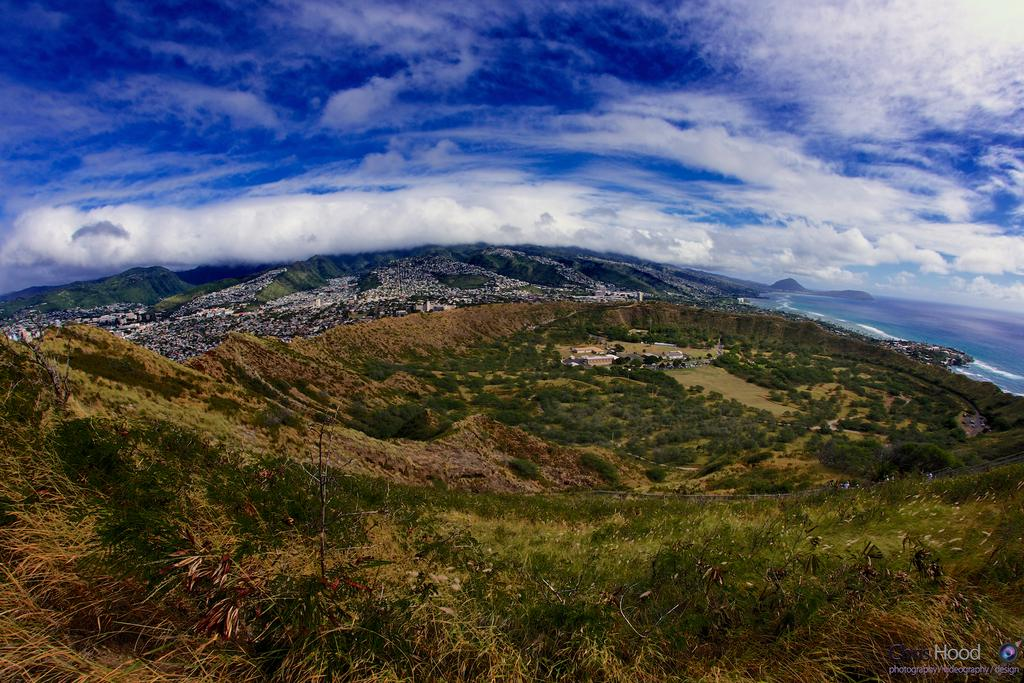What type of landscape is depicted in the image? There is a mountain valley in the image. What can be seen in the valley? The valley is full of trees and dry grass. What is visible at the top of the image? The sky is visible at the top of the image. What can be observed in the sky? Clouds are present in the sky. Where is the writer working in the image? There is no writer present in the image; it depicts a mountain valley with trees, dry grass, and clouds in the sky. 